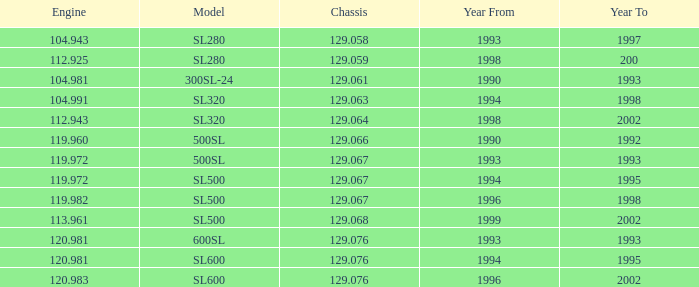Which Engine has a Model of sl500, and a Chassis smaller than 129.067? None. Parse the table in full. {'header': ['Engine', 'Model', 'Chassis', 'Year From', 'Year To'], 'rows': [['104.943', 'SL280', '129.058', '1993', '1997'], ['112.925', 'SL280', '129.059', '1998', '200'], ['104.981', '300SL-24', '129.061', '1990', '1993'], ['104.991', 'SL320', '129.063', '1994', '1998'], ['112.943', 'SL320', '129.064', '1998', '2002'], ['119.960', '500SL', '129.066', '1990', '1992'], ['119.972', '500SL', '129.067', '1993', '1993'], ['119.972', 'SL500', '129.067', '1994', '1995'], ['119.982', 'SL500', '129.067', '1996', '1998'], ['113.961', 'SL500', '129.068', '1999', '2002'], ['120.981', '600SL', '129.076', '1993', '1993'], ['120.981', 'SL600', '129.076', '1994', '1995'], ['120.983', 'SL600', '129.076', '1996', '2002']]} 